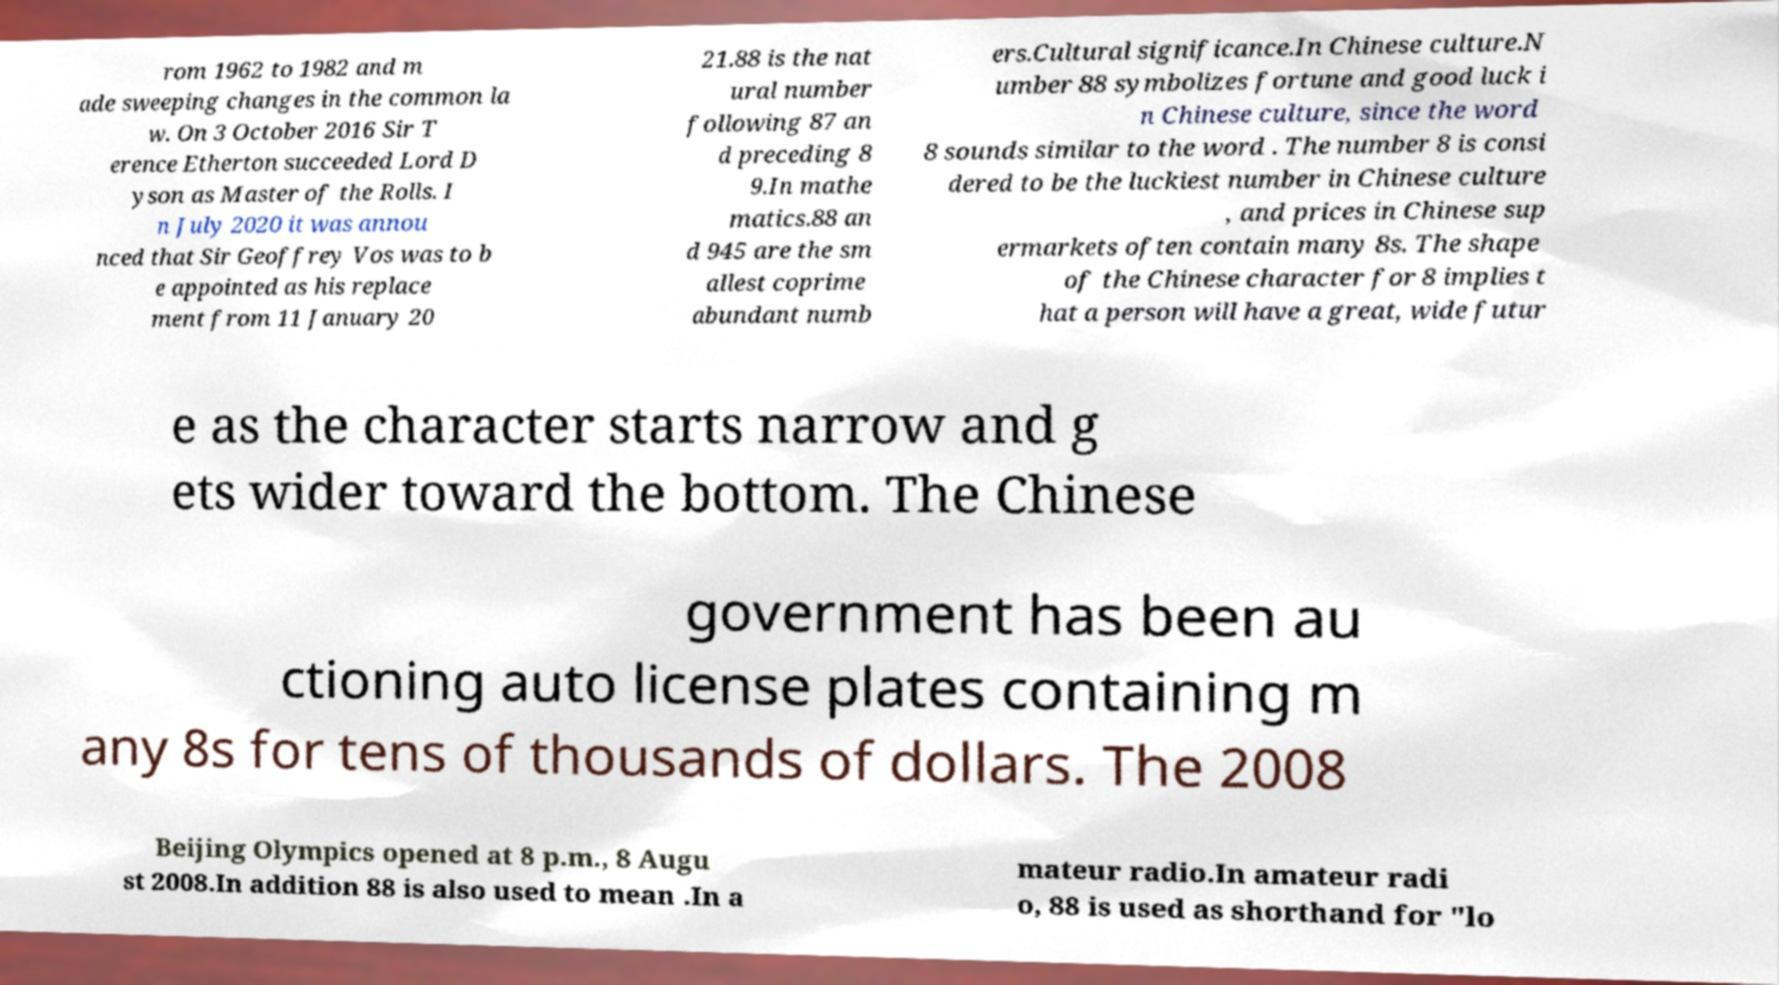There's text embedded in this image that I need extracted. Can you transcribe it verbatim? rom 1962 to 1982 and m ade sweeping changes in the common la w. On 3 October 2016 Sir T erence Etherton succeeded Lord D yson as Master of the Rolls. I n July 2020 it was annou nced that Sir Geoffrey Vos was to b e appointed as his replace ment from 11 January 20 21.88 is the nat ural number following 87 an d preceding 8 9.In mathe matics.88 an d 945 are the sm allest coprime abundant numb ers.Cultural significance.In Chinese culture.N umber 88 symbolizes fortune and good luck i n Chinese culture, since the word 8 sounds similar to the word . The number 8 is consi dered to be the luckiest number in Chinese culture , and prices in Chinese sup ermarkets often contain many 8s. The shape of the Chinese character for 8 implies t hat a person will have a great, wide futur e as the character starts narrow and g ets wider toward the bottom. The Chinese government has been au ctioning auto license plates containing m any 8s for tens of thousands of dollars. The 2008 Beijing Olympics opened at 8 p.m., 8 Augu st 2008.In addition 88 is also used to mean .In a mateur radio.In amateur radi o, 88 is used as shorthand for "lo 